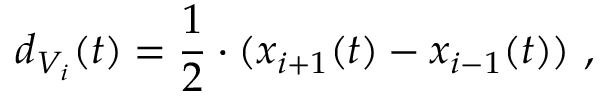Convert formula to latex. <formula><loc_0><loc_0><loc_500><loc_500>d _ { V _ { i } } ( t ) = \frac { 1 } { 2 } \cdot ( x _ { i + 1 } ( t ) - x _ { i - 1 } ( t ) ) \ ,</formula> 